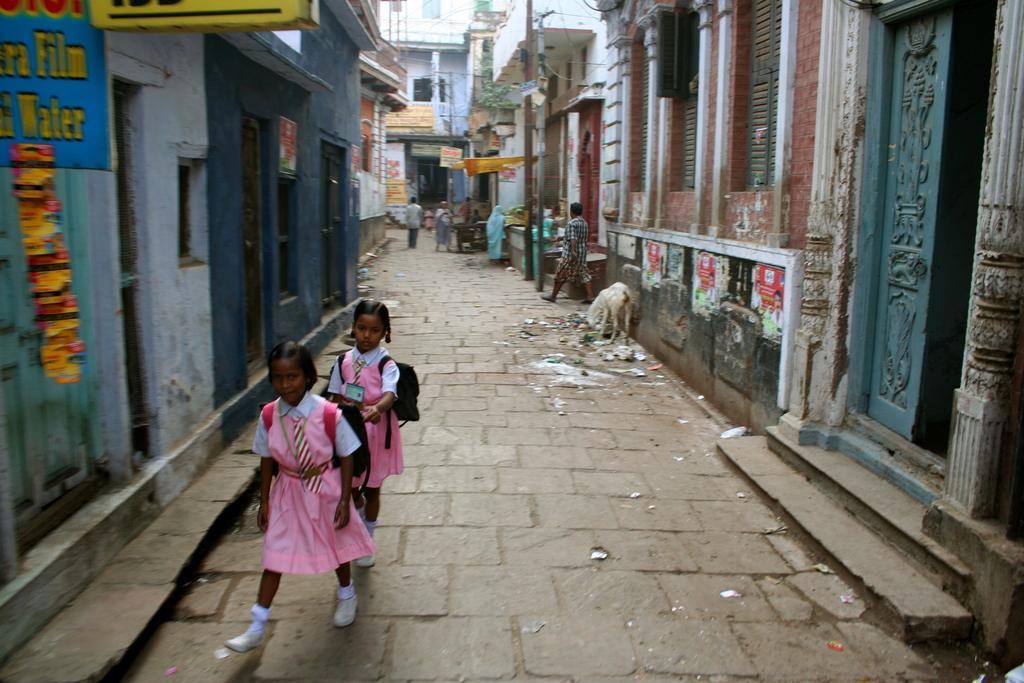Please provide a concise description of this image. In this picture we can see two girls on the path. There are few houses on the right and left side of the image. We can see an animal and other things on the path. There is a pole and a few people in the background. 